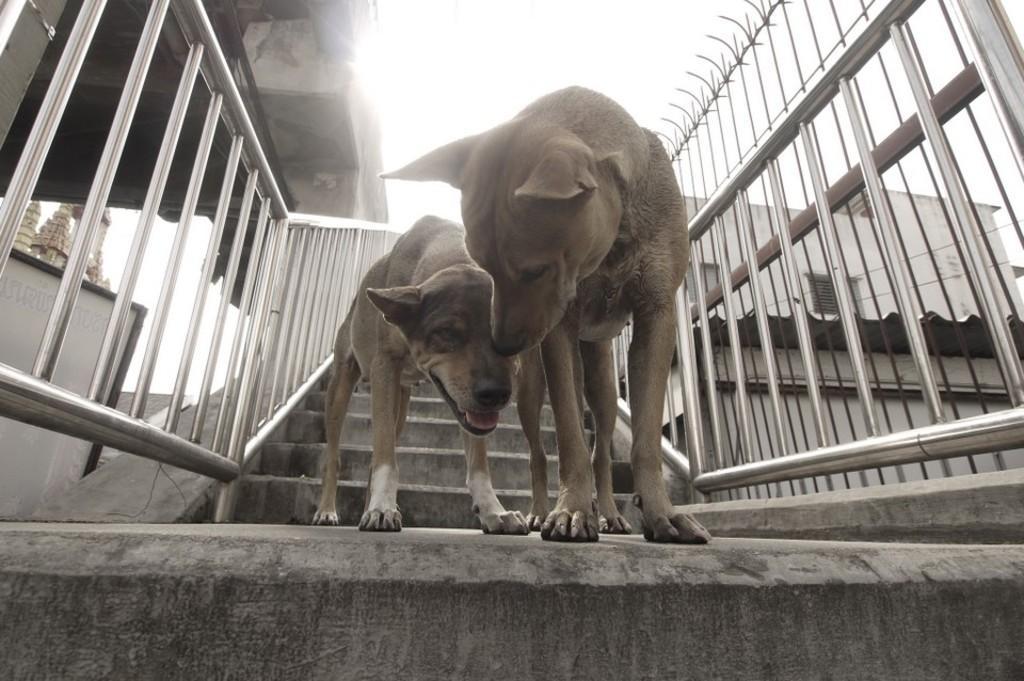Describe this image in one or two sentences. In this picture there are two dogs standing on the staircase. On either side of the image there are hand-grills. In the background there are buildings. 